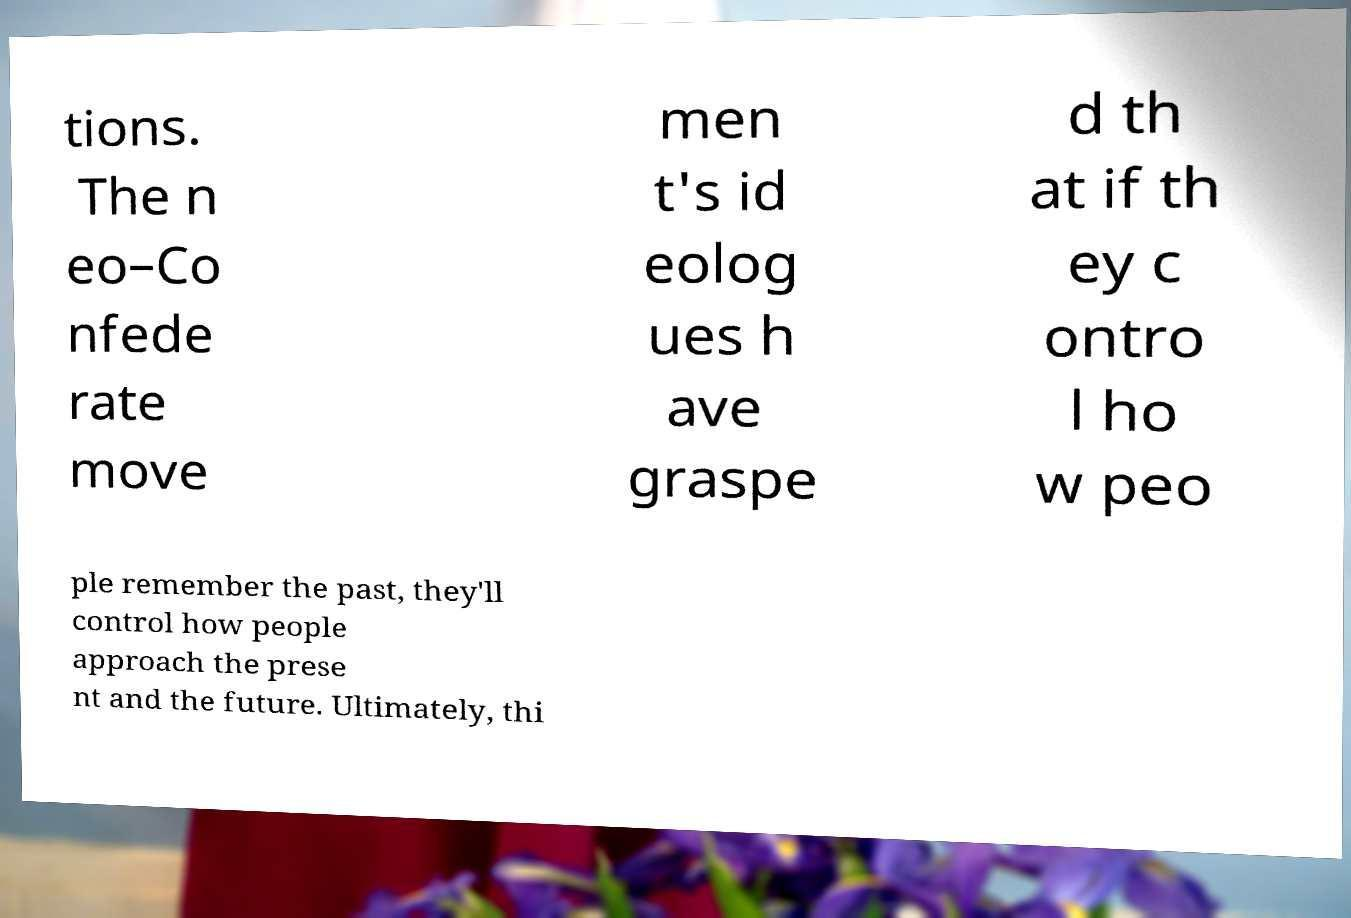Could you extract and type out the text from this image? tions. The n eo–Co nfede rate move men t's id eolog ues h ave graspe d th at if th ey c ontro l ho w peo ple remember the past, they'll control how people approach the prese nt and the future. Ultimately, thi 